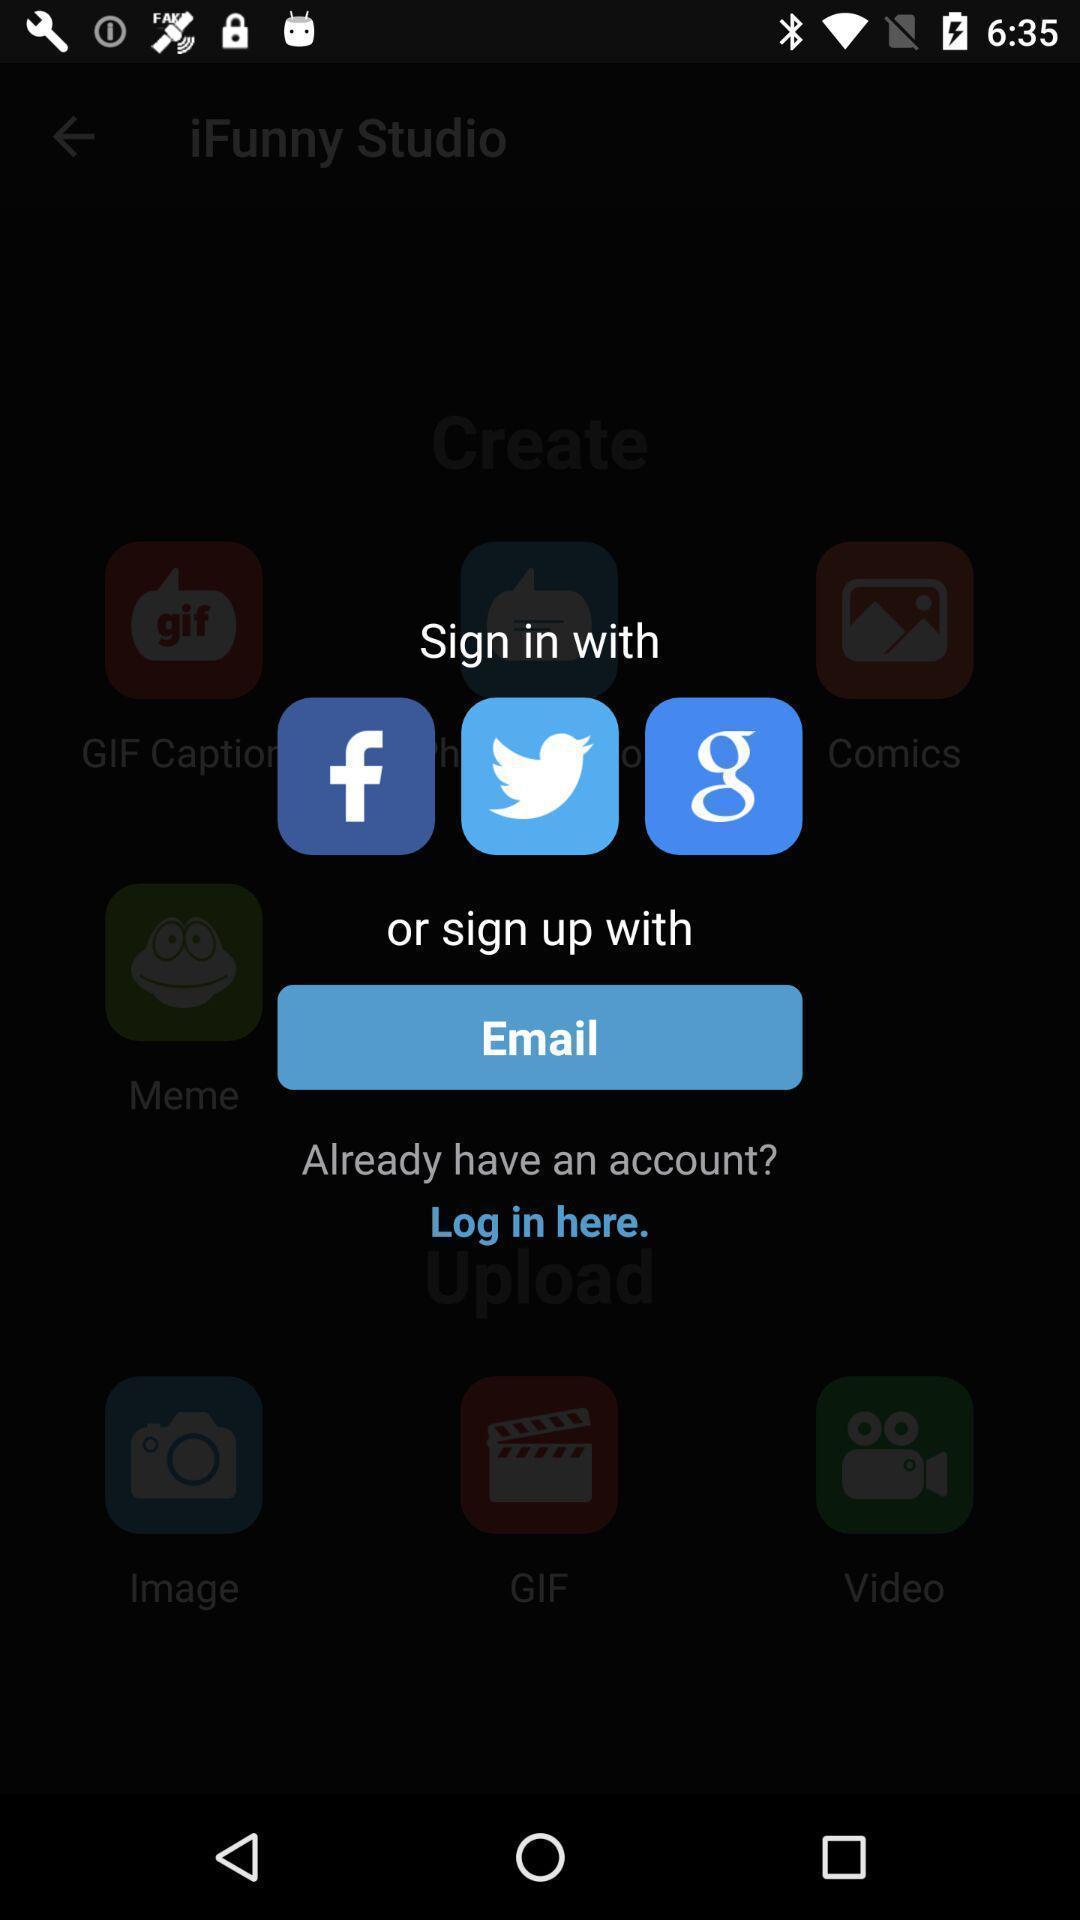Describe the content in this image. Sign in page. 